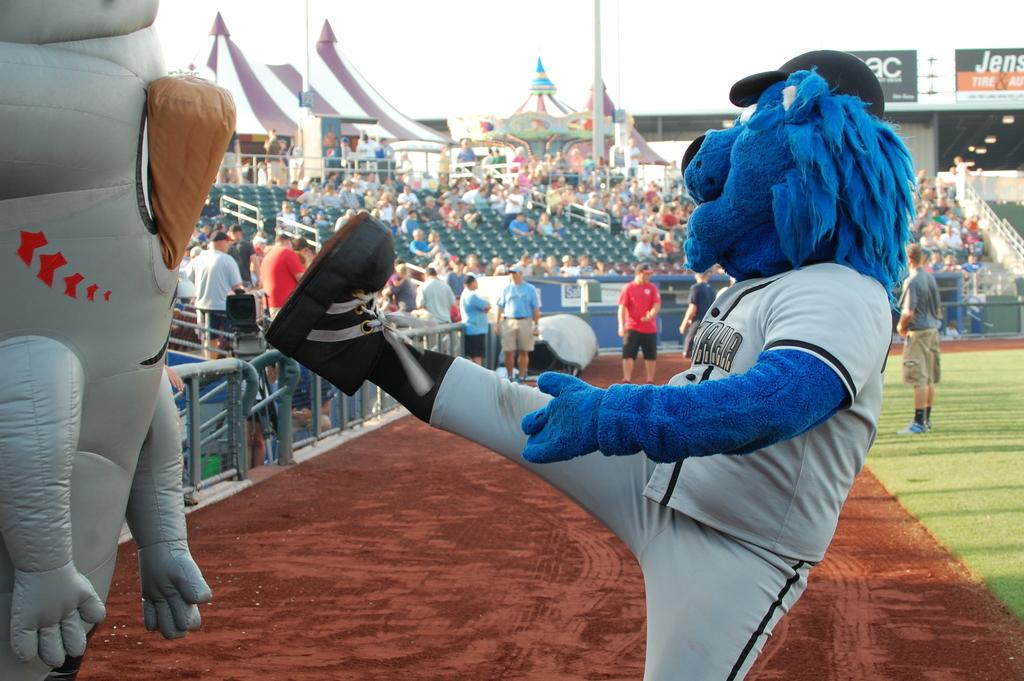<image>
Provide a brief description of the given image. a mascot raises its leg as the word Jens can be seen in the background. 